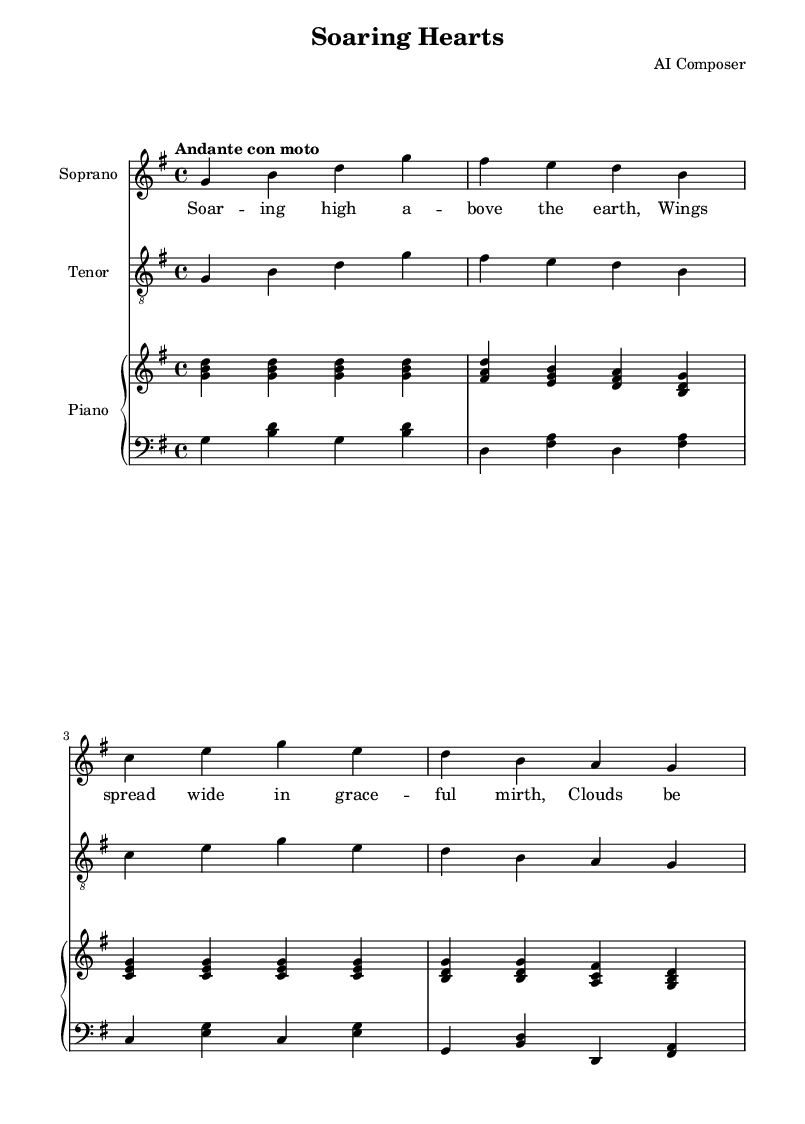What is the key signature of this music? The key signature is G major, which contains one sharp (F#). This can be identified by looking at the beginning of the staff, where the sharp symbol appears.
Answer: G major What is the time signature of this piece? The time signature is 4/4, which indicates four beats per measure. This is noted at the beginning of the score, showing the number "4" both above and below the division bar.
Answer: 4/4 What is the tempo marking? The tempo marking is "Andante con moto", which suggests a moderately slow pace with a slight movement. This is indicated at the start of the score, guiding performers on the speed at which to play.
Answer: Andante con moto What instruments are featured in this score? The score features soprano, tenor, and piano. This is evident from the labels above each staff, indicating their respective parts and roles in the performance.
Answer: Soprano, Tenor, Piano How many measures are in the soprano part? There are four measures in the soprano part. By counting the distinct groupings separated by vertical lines in the soprano staff, we can determine the total number of measures present.
Answer: 4 What is the thematic focus of the lyrics? The thematic focus of the lyrics revolves around flight and freedom. This can be derived from key phrases such as "soaring high" and "dance of freedom" mentioned in the text.
Answer: Flight and Freedom What is the dynamic indication for the soprano and tenor parts? The dynamic indication is "dynamicUp", which suggests that both vocal parts should project their sound outward. This symbol typically signifies a direction for articulation and volume when performed.
Answer: dynamicUp 